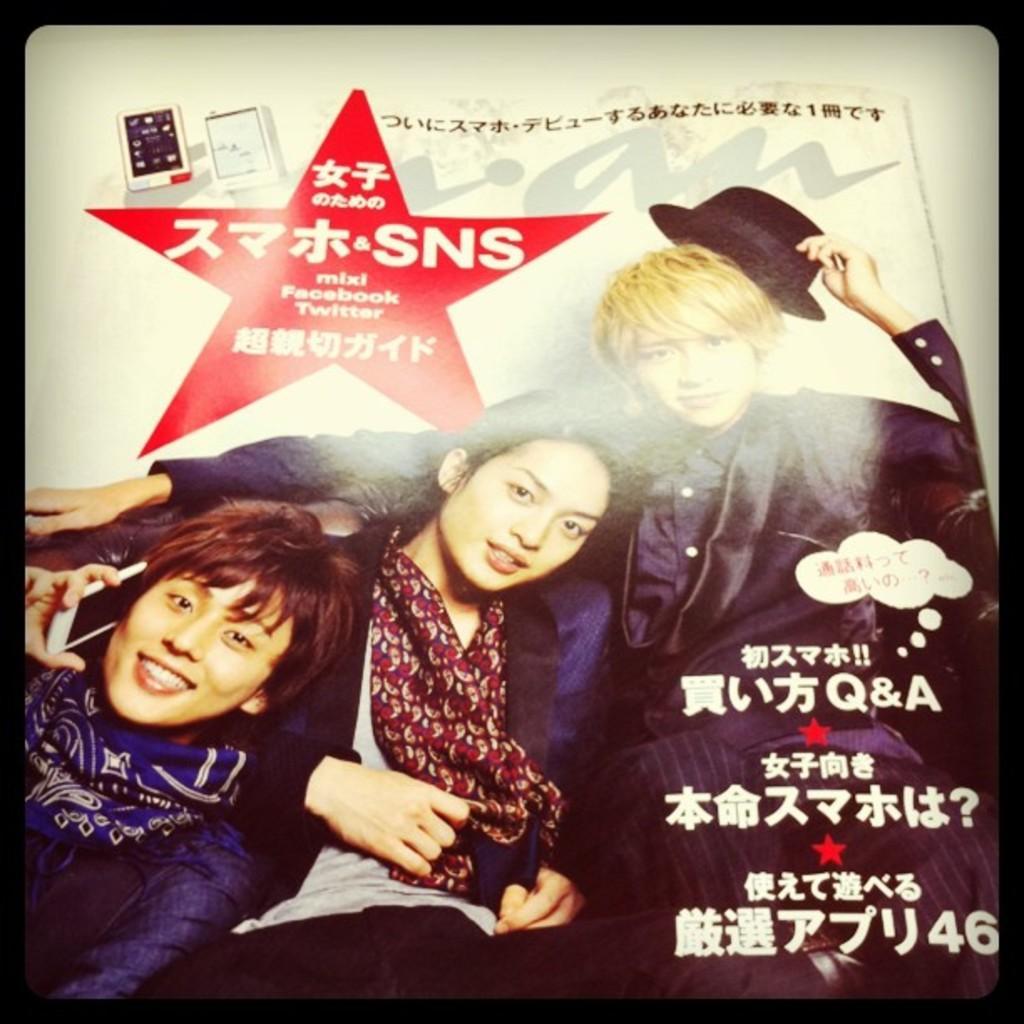Please provide a concise description of this image. In the picture I can see a man and two women among them the man is is holding a hat in the hand and the woman on the left side is holding a mobile in the hand. I can also see something written on the image. 